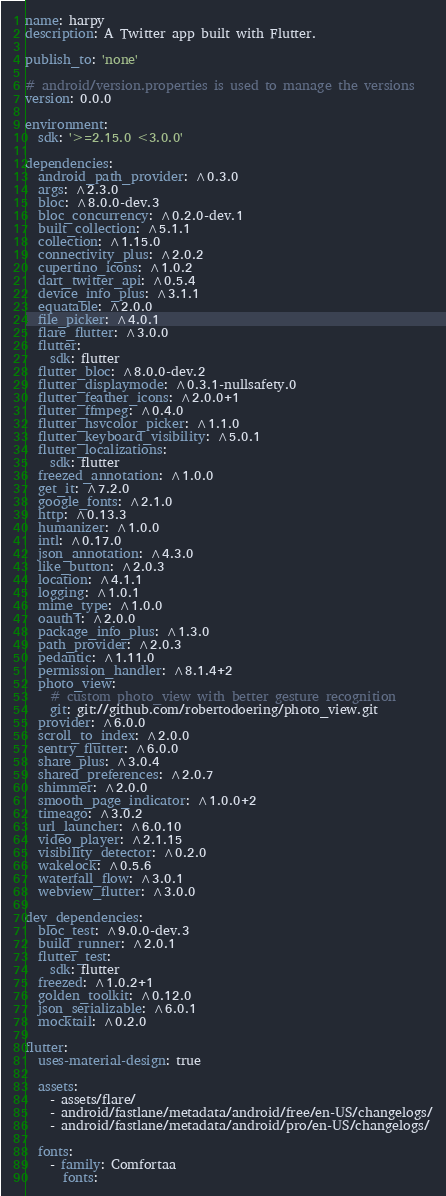Convert code to text. <code><loc_0><loc_0><loc_500><loc_500><_YAML_>name: harpy
description: A Twitter app built with Flutter.

publish_to: 'none'

# android/version.properties is used to manage the versions
version: 0.0.0

environment:
  sdk: '>=2.15.0 <3.0.0'

dependencies:
  android_path_provider: ^0.3.0
  args: ^2.3.0
  bloc: ^8.0.0-dev.3
  bloc_concurrency: ^0.2.0-dev.1
  built_collection: ^5.1.1
  collection: ^1.15.0
  connectivity_plus: ^2.0.2
  cupertino_icons: ^1.0.2
  dart_twitter_api: ^0.5.4
  device_info_plus: ^3.1.1
  equatable: ^2.0.0
  file_picker: ^4.0.1
  flare_flutter: ^3.0.0
  flutter:
    sdk: flutter
  flutter_bloc: ^8.0.0-dev.2
  flutter_displaymode: ^0.3.1-nullsafety.0
  flutter_feather_icons: ^2.0.0+1
  flutter_ffmpeg: ^0.4.0
  flutter_hsvcolor_picker: ^1.1.0
  flutter_keyboard_visibility: ^5.0.1
  flutter_localizations:
    sdk: flutter
  freezed_annotation: ^1.0.0
  get_it: ^7.2.0
  google_fonts: ^2.1.0
  http: ^0.13.3
  humanizer: ^1.0.0
  intl: ^0.17.0
  json_annotation: ^4.3.0
  like_button: ^2.0.3
  location: ^4.1.1
  logging: ^1.0.1
  mime_type: ^1.0.0
  oauth1: ^2.0.0
  package_info_plus: ^1.3.0
  path_provider: ^2.0.3
  pedantic: ^1.11.0
  permission_handler: ^8.1.4+2
  photo_view:
    # custom photo_view with better gesture recognition
    git: git://github.com/robertodoering/photo_view.git
  provider: ^6.0.0
  scroll_to_index: ^2.0.0
  sentry_flutter: ^6.0.0
  share_plus: ^3.0.4
  shared_preferences: ^2.0.7
  shimmer: ^2.0.0
  smooth_page_indicator: ^1.0.0+2
  timeago: ^3.0.2
  url_launcher: ^6.0.10
  video_player: ^2.1.15
  visibility_detector: ^0.2.0
  wakelock: ^0.5.6
  waterfall_flow: ^3.0.1
  webview_flutter: ^3.0.0

dev_dependencies:
  bloc_test: ^9.0.0-dev.3
  build_runner: ^2.0.1
  flutter_test:
    sdk: flutter
  freezed: ^1.0.2+1
  golden_toolkit: ^0.12.0
  json_serializable: ^6.0.1
  mocktail: ^0.2.0

flutter:
  uses-material-design: true

  assets:
    - assets/flare/
    - android/fastlane/metadata/android/free/en-US/changelogs/
    - android/fastlane/metadata/android/pro/en-US/changelogs/

  fonts:
    - family: Comfortaa
      fonts:</code> 